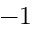Convert formula to latex. <formula><loc_0><loc_0><loc_500><loc_500>- 1</formula> 